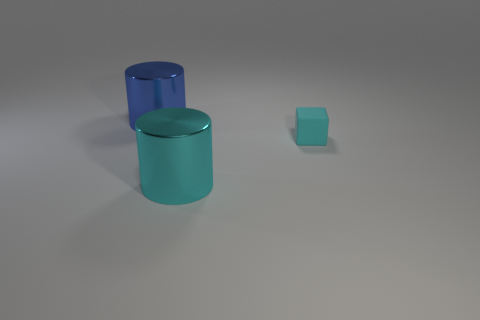Is there any other thing that is the same material as the small cyan object?
Your response must be concise. No. Does the large blue thing have the same material as the small object?
Provide a succinct answer. No. There is a cyan thing that is the same material as the large blue cylinder; what shape is it?
Provide a short and direct response. Cylinder. Are there fewer cyan cubes than tiny green cylinders?
Keep it short and to the point. No. There is a object that is both left of the block and on the right side of the large blue object; what is its material?
Your response must be concise. Metal. What size is the metal thing in front of the thing that is to the left of the metal cylinder that is in front of the small cyan cube?
Your answer should be compact. Large. Is the shape of the big blue thing the same as the cyan thing that is on the right side of the cyan shiny cylinder?
Offer a terse response. No. What number of things are on the right side of the blue thing and behind the large cyan metallic cylinder?
Provide a succinct answer. 1. How many purple objects are large metal cylinders or tiny rubber things?
Provide a succinct answer. 0. There is a large object in front of the tiny cyan block; does it have the same color as the thing to the right of the large cyan object?
Give a very brief answer. Yes. 